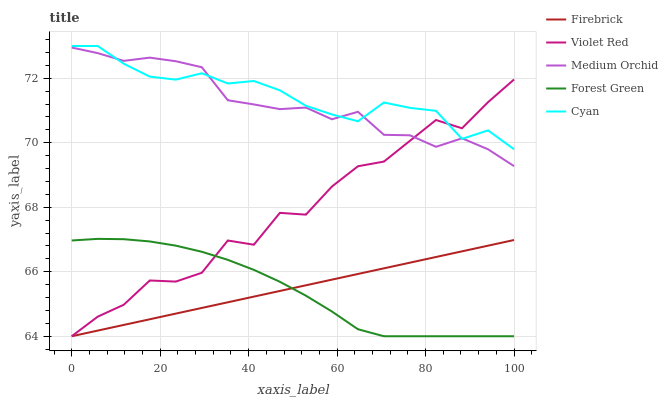Does Forest Green have the minimum area under the curve?
Answer yes or no. Yes. Does Cyan have the maximum area under the curve?
Answer yes or no. Yes. Does Firebrick have the minimum area under the curve?
Answer yes or no. No. Does Firebrick have the maximum area under the curve?
Answer yes or no. No. Is Firebrick the smoothest?
Answer yes or no. Yes. Is Violet Red the roughest?
Answer yes or no. Yes. Is Cyan the smoothest?
Answer yes or no. No. Is Cyan the roughest?
Answer yes or no. No. Does Forest Green have the lowest value?
Answer yes or no. Yes. Does Cyan have the lowest value?
Answer yes or no. No. Does Cyan have the highest value?
Answer yes or no. Yes. Does Firebrick have the highest value?
Answer yes or no. No. Is Firebrick less than Medium Orchid?
Answer yes or no. Yes. Is Medium Orchid greater than Firebrick?
Answer yes or no. Yes. Does Cyan intersect Violet Red?
Answer yes or no. Yes. Is Cyan less than Violet Red?
Answer yes or no. No. Is Cyan greater than Violet Red?
Answer yes or no. No. Does Firebrick intersect Medium Orchid?
Answer yes or no. No. 